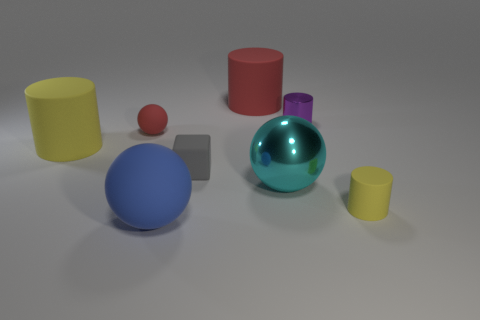What can you infer about the lighting in the image? The lighting in the image seems to be diffuse and soft, originating from the top or slightly to the left of the scene, as indicated by the gentle shadows cast on the right side of the objects. There are no harsh reflections or strong specular highlights, suggesting the light source is either large or not directly visible, possibly mimicking the effect of an overcast sky or softbox used in photography to reduce shadow contrast. 